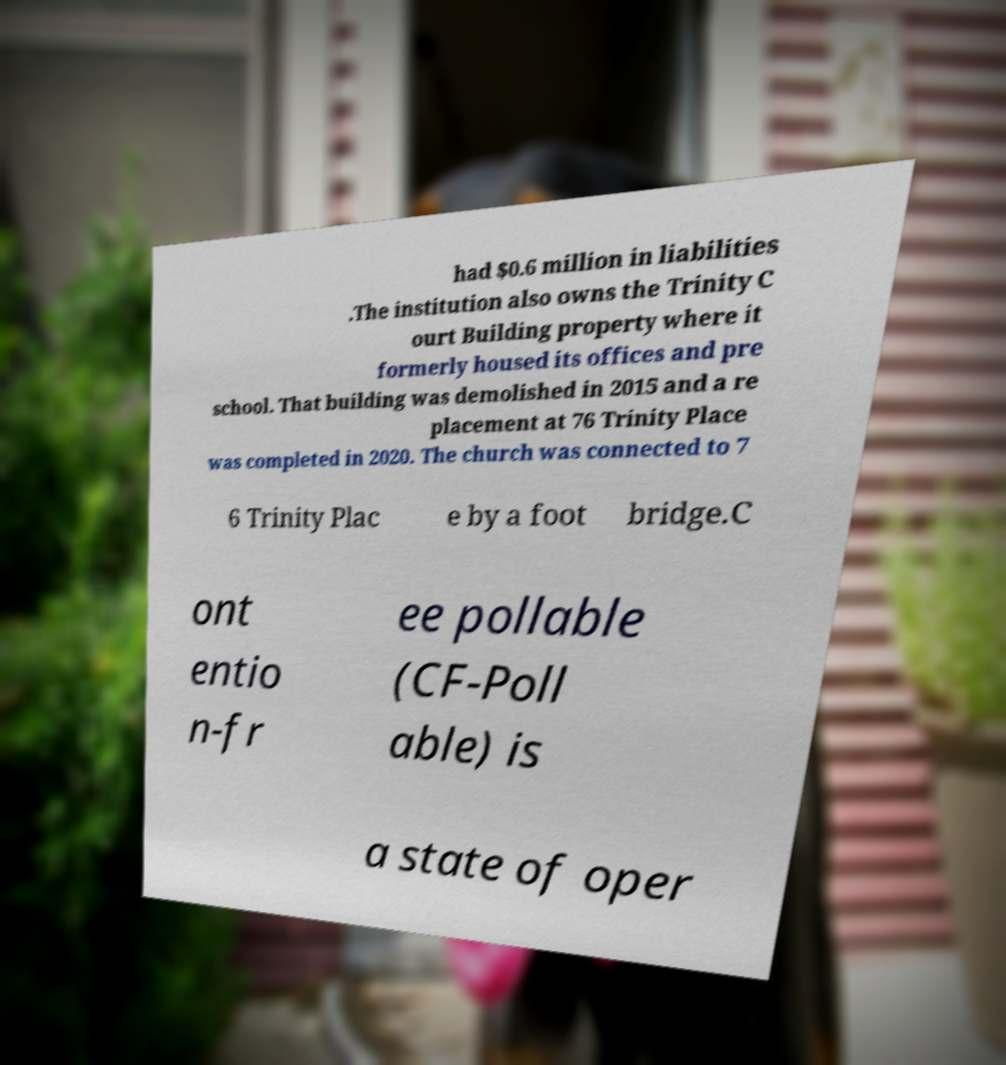Could you extract and type out the text from this image? had $0.6 million in liabilities .The institution also owns the Trinity C ourt Building property where it formerly housed its offices and pre school. That building was demolished in 2015 and a re placement at 76 Trinity Place was completed in 2020. The church was connected to 7 6 Trinity Plac e by a foot bridge.C ont entio n-fr ee pollable (CF-Poll able) is a state of oper 